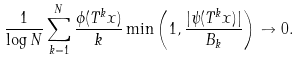Convert formula to latex. <formula><loc_0><loc_0><loc_500><loc_500>\frac { 1 } { \log N } \sum _ { k = 1 } ^ { N } \frac { \phi ( T ^ { k } x ) } { k } \min \left ( 1 , \frac { | \psi ( T ^ { k } x ) | } { B _ { k } } \right ) \to 0 .</formula> 